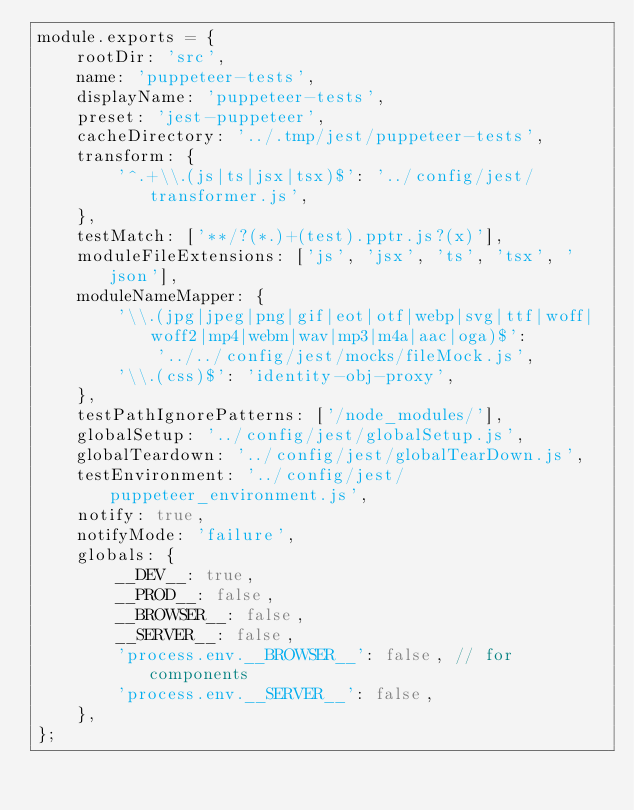<code> <loc_0><loc_0><loc_500><loc_500><_JavaScript_>module.exports = {
    rootDir: 'src',
    name: 'puppeteer-tests',
    displayName: 'puppeteer-tests',
    preset: 'jest-puppeteer',
    cacheDirectory: '../.tmp/jest/puppeteer-tests',
    transform: {
        '^.+\\.(js|ts|jsx|tsx)$': '../config/jest/transformer.js',
    },
    testMatch: ['**/?(*.)+(test).pptr.js?(x)'],
    moduleFileExtensions: ['js', 'jsx', 'ts', 'tsx', 'json'],
    moduleNameMapper: {
        '\\.(jpg|jpeg|png|gif|eot|otf|webp|svg|ttf|woff|woff2|mp4|webm|wav|mp3|m4a|aac|oga)$':
            '../../config/jest/mocks/fileMock.js',
        '\\.(css)$': 'identity-obj-proxy',
    },
    testPathIgnorePatterns: ['/node_modules/'],
    globalSetup: '../config/jest/globalSetup.js',
    globalTeardown: '../config/jest/globalTearDown.js',
    testEnvironment: '../config/jest/puppeteer_environment.js',
    notify: true,
    notifyMode: 'failure',
    globals: {
        __DEV__: true,
        __PROD__: false,
        __BROWSER__: false,
        __SERVER__: false,
        'process.env.__BROWSER__': false, // for components
        'process.env.__SERVER__': false,
    },
};
</code> 